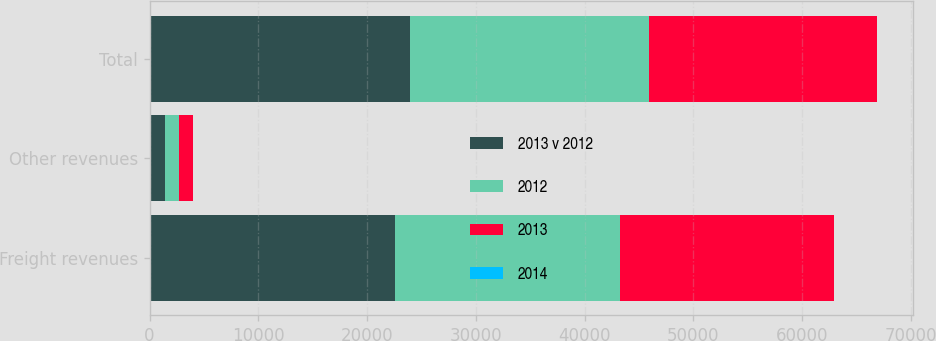<chart> <loc_0><loc_0><loc_500><loc_500><stacked_bar_chart><ecel><fcel>Freight revenues<fcel>Other revenues<fcel>Total<nl><fcel>2013 v 2012<fcel>22560<fcel>1428<fcel>23988<nl><fcel>2012<fcel>20684<fcel>1279<fcel>21963<nl><fcel>2013<fcel>19686<fcel>1240<fcel>20926<nl><fcel>2014<fcel>9<fcel>12<fcel>9<nl></chart> 